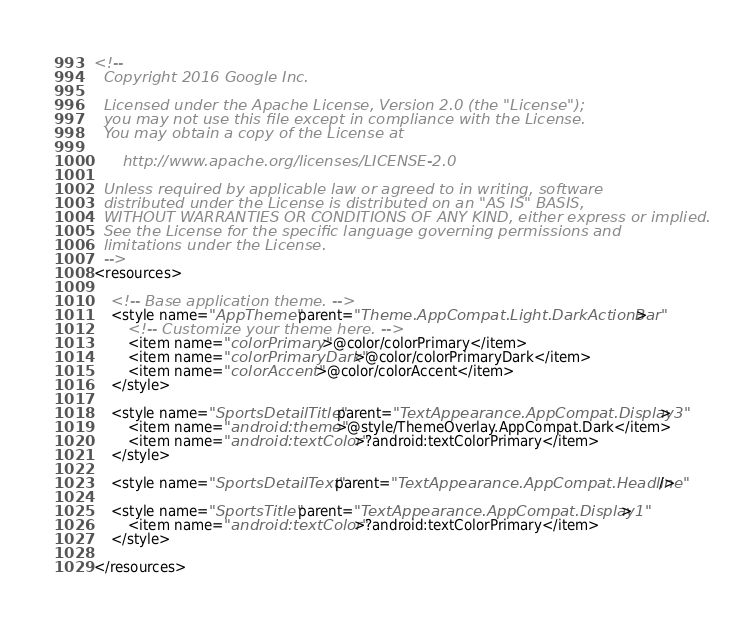Convert code to text. <code><loc_0><loc_0><loc_500><loc_500><_XML_><!--
  Copyright 2016 Google Inc.

  Licensed under the Apache License, Version 2.0 (the "License");
  you may not use this file except in compliance with the License.
  You may obtain a copy of the License at

      http://www.apache.org/licenses/LICENSE-2.0

  Unless required by applicable law or agreed to in writing, software
  distributed under the License is distributed on an "AS IS" BASIS,
  WITHOUT WARRANTIES OR CONDITIONS OF ANY KIND, either express or implied.
  See the License for the specific language governing permissions and
  limitations under the License.
  -->
<resources>

    <!-- Base application theme. -->
    <style name="AppTheme" parent="Theme.AppCompat.Light.DarkActionBar">
        <!-- Customize your theme here. -->
        <item name="colorPrimary">@color/colorPrimary</item>
        <item name="colorPrimaryDark">@color/colorPrimaryDark</item>
        <item name="colorAccent">@color/colorAccent</item>
    </style>

    <style name="SportsDetailTitle" parent="TextAppearance.AppCompat.Display3">
        <item name="android:theme">@style/ThemeOverlay.AppCompat.Dark</item>
        <item name="android:textColor">?android:textColorPrimary</item>
    </style>

    <style name="SportsDetailText" parent="TextAppearance.AppCompat.Headline"/>

    <style name="SportsTitle" parent="TextAppearance.AppCompat.Display1">
        <item name="android:textColor">?android:textColorPrimary</item>
    </style>

</resources>
</code> 